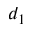<formula> <loc_0><loc_0><loc_500><loc_500>d _ { 1 }</formula> 